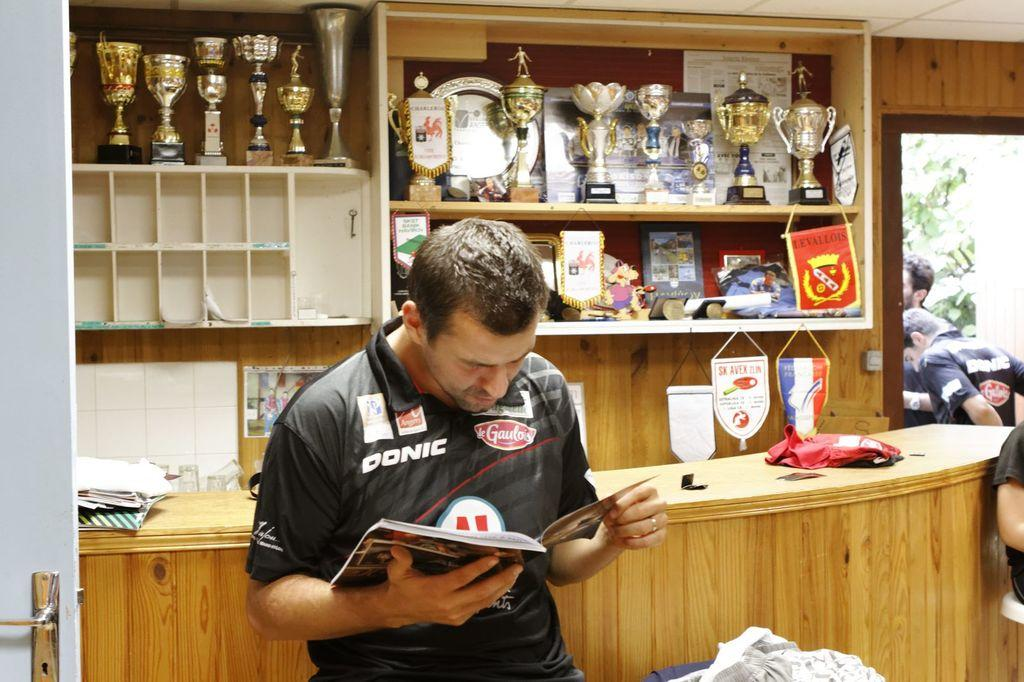Provide a one-sentence caption for the provided image. A man with a shirt that has the Donis logo is reading a book. 